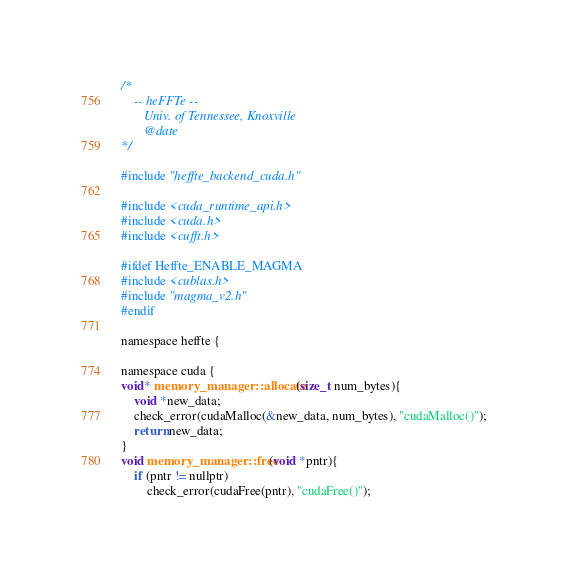Convert code to text. <code><loc_0><loc_0><loc_500><loc_500><_Cuda_>/*
    -- heFFTe --
       Univ. of Tennessee, Knoxville
       @date
*/

#include "heffte_backend_cuda.h"

#include <cuda_runtime_api.h>
#include <cuda.h>
#include <cufft.h>

#ifdef Heffte_ENABLE_MAGMA
#include <cublas.h>
#include "magma_v2.h"
#endif

namespace heffte {

namespace cuda {
void* memory_manager::allocate(size_t num_bytes){
    void *new_data;
    check_error(cudaMalloc(&new_data, num_bytes), "cudaMalloc()");
    return new_data;
}
void memory_manager::free(void *pntr){
    if (pntr != nullptr)
        check_error(cudaFree(pntr), "cudaFree()");</code> 